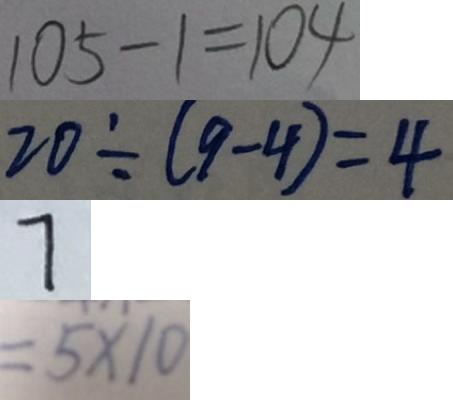Convert formula to latex. <formula><loc_0><loc_0><loc_500><loc_500>1 0 5 - 1 = 1 0 4 
 2 0 \div ( 9 - 4 ) = 4 
 7 
 = 5 \times 1 0</formula> 